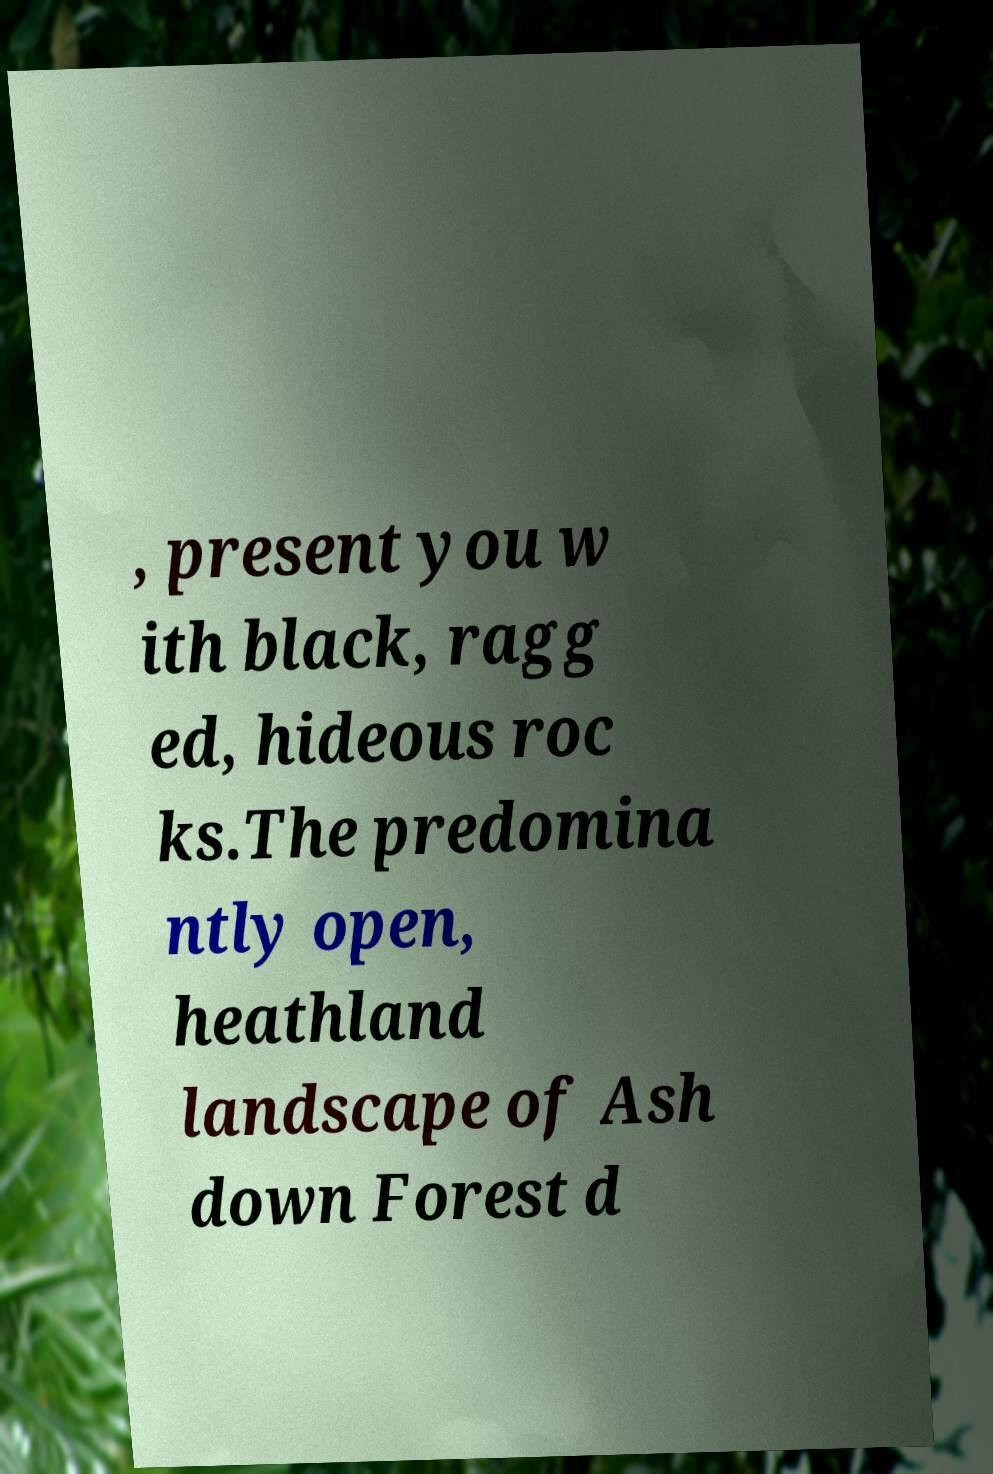I need the written content from this picture converted into text. Can you do that? , present you w ith black, ragg ed, hideous roc ks.The predomina ntly open, heathland landscape of Ash down Forest d 